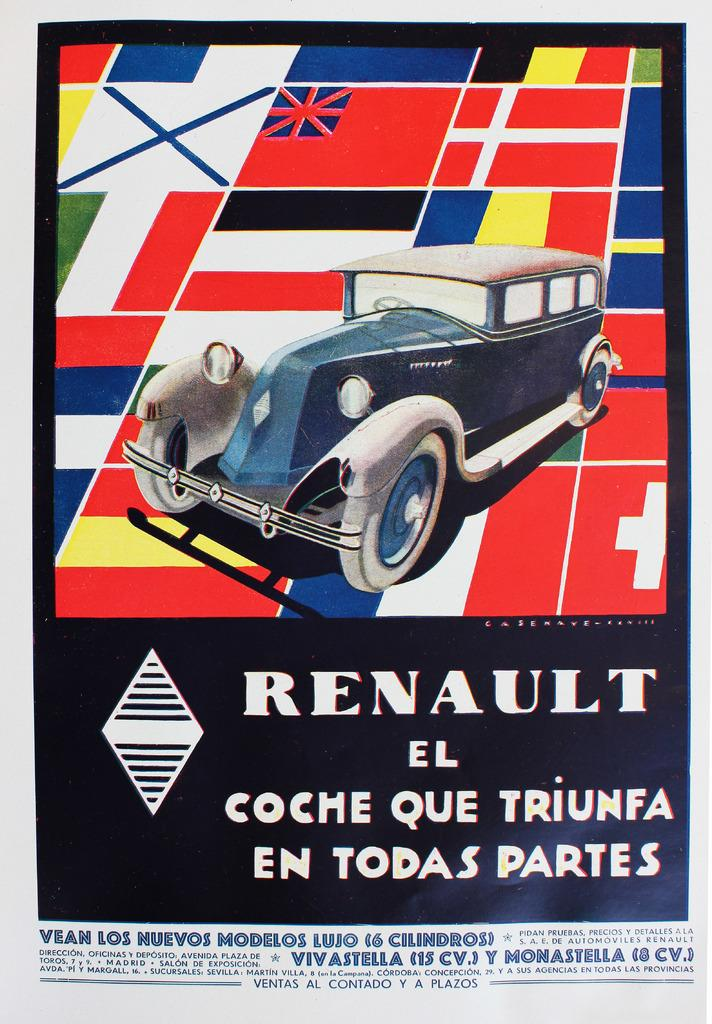What is depicted on the poster in the image? The poster features a car. What brand of car is shown on the poster? The word "RENAULT" is printed on the poster, indicating that it is a Renault car. What type of ghost can be seen driving the car on the poster? There is no ghost present in the image; the car is not being driven by any ghost. 